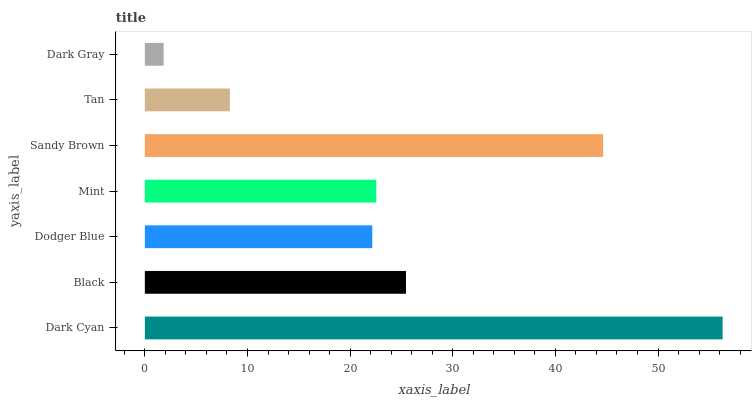Is Dark Gray the minimum?
Answer yes or no. Yes. Is Dark Cyan the maximum?
Answer yes or no. Yes. Is Black the minimum?
Answer yes or no. No. Is Black the maximum?
Answer yes or no. No. Is Dark Cyan greater than Black?
Answer yes or no. Yes. Is Black less than Dark Cyan?
Answer yes or no. Yes. Is Black greater than Dark Cyan?
Answer yes or no. No. Is Dark Cyan less than Black?
Answer yes or no. No. Is Mint the high median?
Answer yes or no. Yes. Is Mint the low median?
Answer yes or no. Yes. Is Black the high median?
Answer yes or no. No. Is Sandy Brown the low median?
Answer yes or no. No. 